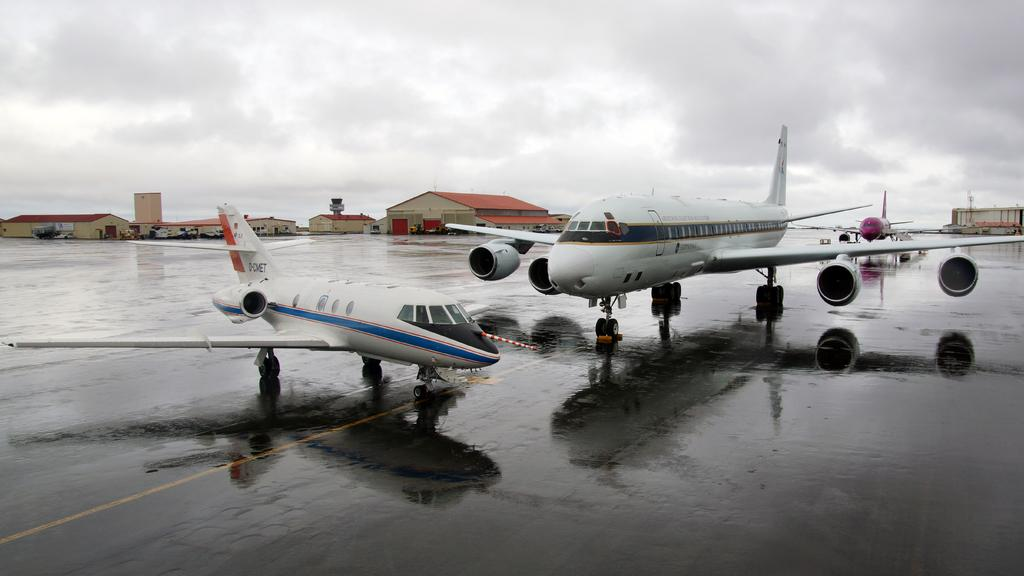What is the main subject of the image? The main subject of the image is planes. What else can be seen in the image besides the planes? There is a road, houses, and the sky visible in the image. What is the condition of the sky in the image? The sky is visible in the background of the image, and there are clouds in the sky. What type of quilt is being used to cover the furniture in the image? There is no quilt or furniture present in the image; it features planes, a road, houses, and the sky. 